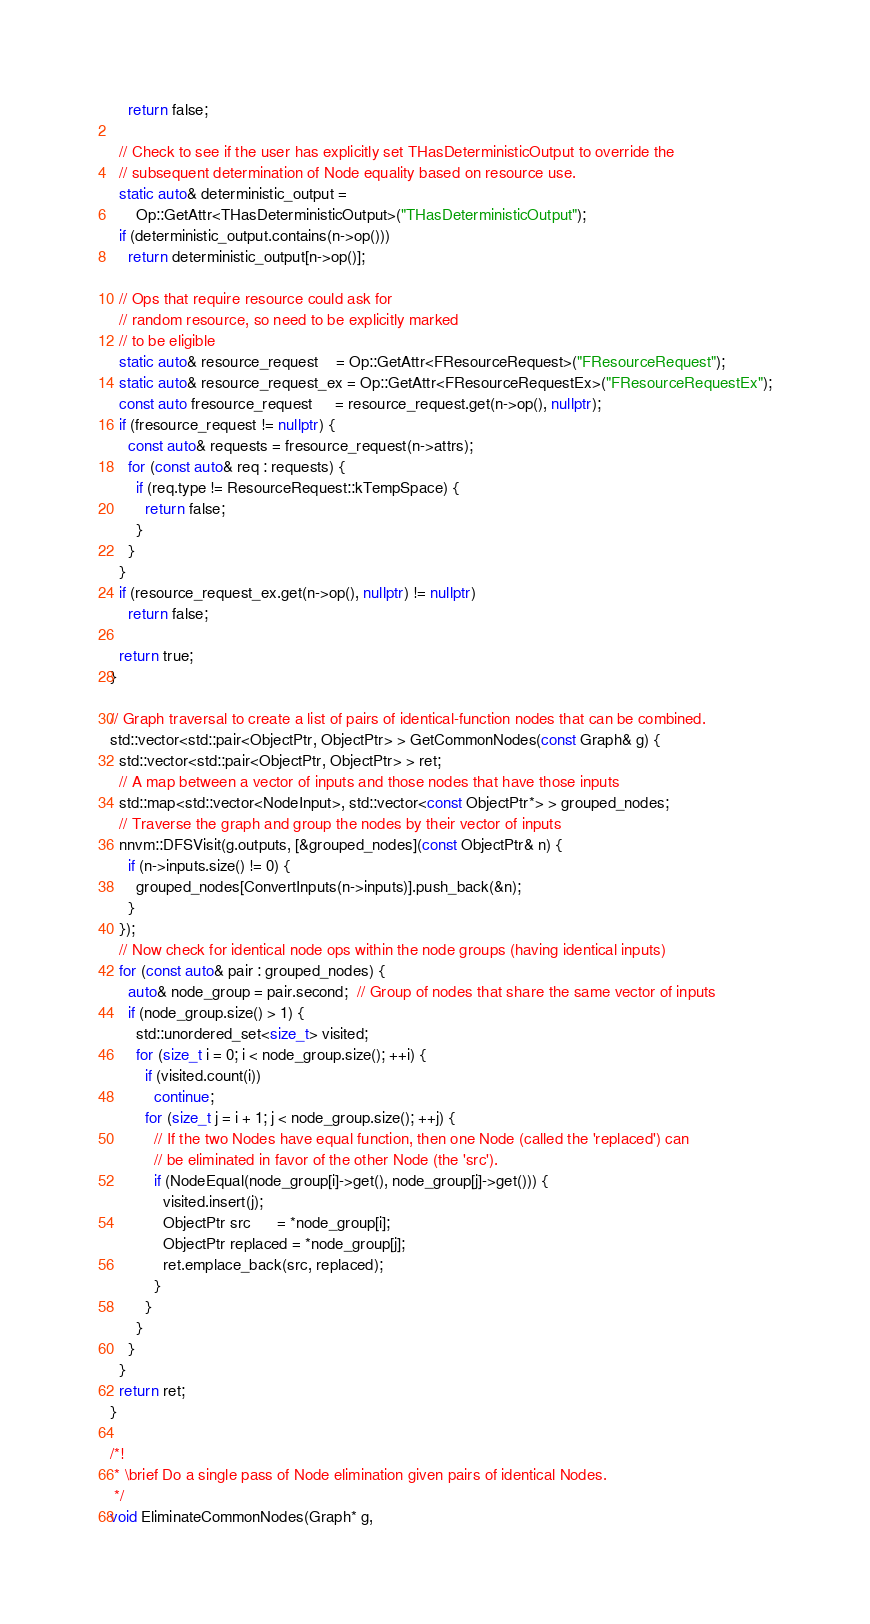<code> <loc_0><loc_0><loc_500><loc_500><_C++_>    return false;

  // Check to see if the user has explicitly set THasDeterministicOutput to override the
  // subsequent determination of Node equality based on resource use.
  static auto& deterministic_output =
      Op::GetAttr<THasDeterministicOutput>("THasDeterministicOutput");
  if (deterministic_output.contains(n->op()))
    return deterministic_output[n->op()];

  // Ops that require resource could ask for
  // random resource, so need to be explicitly marked
  // to be eligible
  static auto& resource_request    = Op::GetAttr<FResourceRequest>("FResourceRequest");
  static auto& resource_request_ex = Op::GetAttr<FResourceRequestEx>("FResourceRequestEx");
  const auto fresource_request     = resource_request.get(n->op(), nullptr);
  if (fresource_request != nullptr) {
    const auto& requests = fresource_request(n->attrs);
    for (const auto& req : requests) {
      if (req.type != ResourceRequest::kTempSpace) {
        return false;
      }
    }
  }
  if (resource_request_ex.get(n->op(), nullptr) != nullptr)
    return false;

  return true;
}

// Graph traversal to create a list of pairs of identical-function nodes that can be combined.
std::vector<std::pair<ObjectPtr, ObjectPtr> > GetCommonNodes(const Graph& g) {
  std::vector<std::pair<ObjectPtr, ObjectPtr> > ret;
  // A map between a vector of inputs and those nodes that have those inputs
  std::map<std::vector<NodeInput>, std::vector<const ObjectPtr*> > grouped_nodes;
  // Traverse the graph and group the nodes by their vector of inputs
  nnvm::DFSVisit(g.outputs, [&grouped_nodes](const ObjectPtr& n) {
    if (n->inputs.size() != 0) {
      grouped_nodes[ConvertInputs(n->inputs)].push_back(&n);
    }
  });
  // Now check for identical node ops within the node groups (having identical inputs)
  for (const auto& pair : grouped_nodes) {
    auto& node_group = pair.second;  // Group of nodes that share the same vector of inputs
    if (node_group.size() > 1) {
      std::unordered_set<size_t> visited;
      for (size_t i = 0; i < node_group.size(); ++i) {
        if (visited.count(i))
          continue;
        for (size_t j = i + 1; j < node_group.size(); ++j) {
          // If the two Nodes have equal function, then one Node (called the 'replaced') can
          // be eliminated in favor of the other Node (the 'src').
          if (NodeEqual(node_group[i]->get(), node_group[j]->get())) {
            visited.insert(j);
            ObjectPtr src      = *node_group[i];
            ObjectPtr replaced = *node_group[j];
            ret.emplace_back(src, replaced);
          }
        }
      }
    }
  }
  return ret;
}

/*!
 * \brief Do a single pass of Node elimination given pairs of identical Nodes.
 */
void EliminateCommonNodes(Graph* g,</code> 